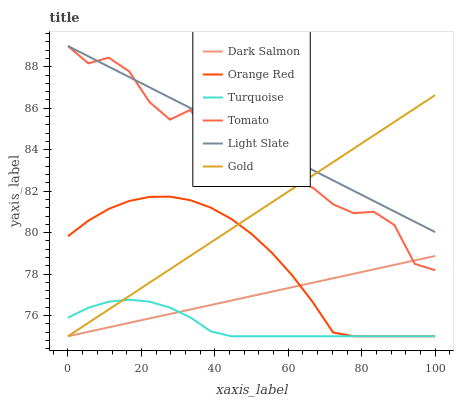Does Turquoise have the minimum area under the curve?
Answer yes or no. Yes. Does Light Slate have the maximum area under the curve?
Answer yes or no. Yes. Does Gold have the minimum area under the curve?
Answer yes or no. No. Does Gold have the maximum area under the curve?
Answer yes or no. No. Is Light Slate the smoothest?
Answer yes or no. Yes. Is Tomato the roughest?
Answer yes or no. Yes. Is Turquoise the smoothest?
Answer yes or no. No. Is Turquoise the roughest?
Answer yes or no. No. Does Turquoise have the lowest value?
Answer yes or no. Yes. Does Light Slate have the lowest value?
Answer yes or no. No. Does Light Slate have the highest value?
Answer yes or no. Yes. Does Gold have the highest value?
Answer yes or no. No. Is Orange Red less than Tomato?
Answer yes or no. Yes. Is Light Slate greater than Dark Salmon?
Answer yes or no. Yes. Does Gold intersect Light Slate?
Answer yes or no. Yes. Is Gold less than Light Slate?
Answer yes or no. No. Is Gold greater than Light Slate?
Answer yes or no. No. Does Orange Red intersect Tomato?
Answer yes or no. No. 